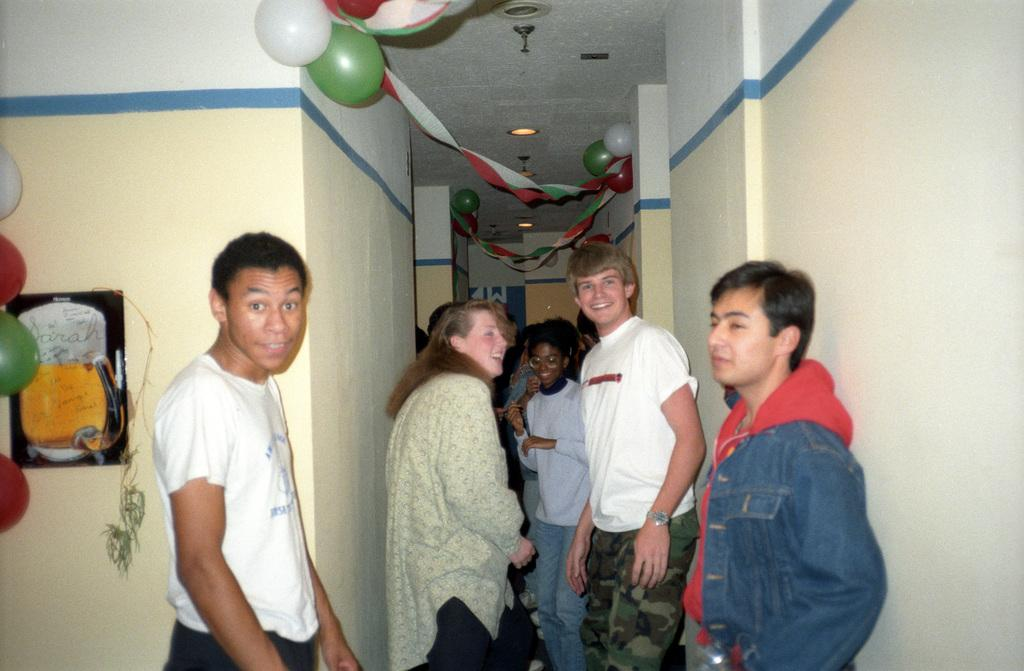What type of structure can be seen in the image? There is a wall in the image. What decorative items are present in the image? There are balloons and a poster in the image. Are there any people visible in the image? Yes, there are people present in the image. Reasoning: Let' Let's think step by step in order to produce the conversation. We start by identifying the main structure in the image, which is the wall. Then, we describe the decorative items present, which are the balloons and the poster. Finally, we confirm the presence of people in the image. Each question is designed to elicit a specific detail about the image that is known from the provided facts. Absurd Question/Answer: Where is the cactus located in the image? There is no cactus present in the image. What type of food is being served in the lunchroom in the image? There is no lunchroom present in the image. 